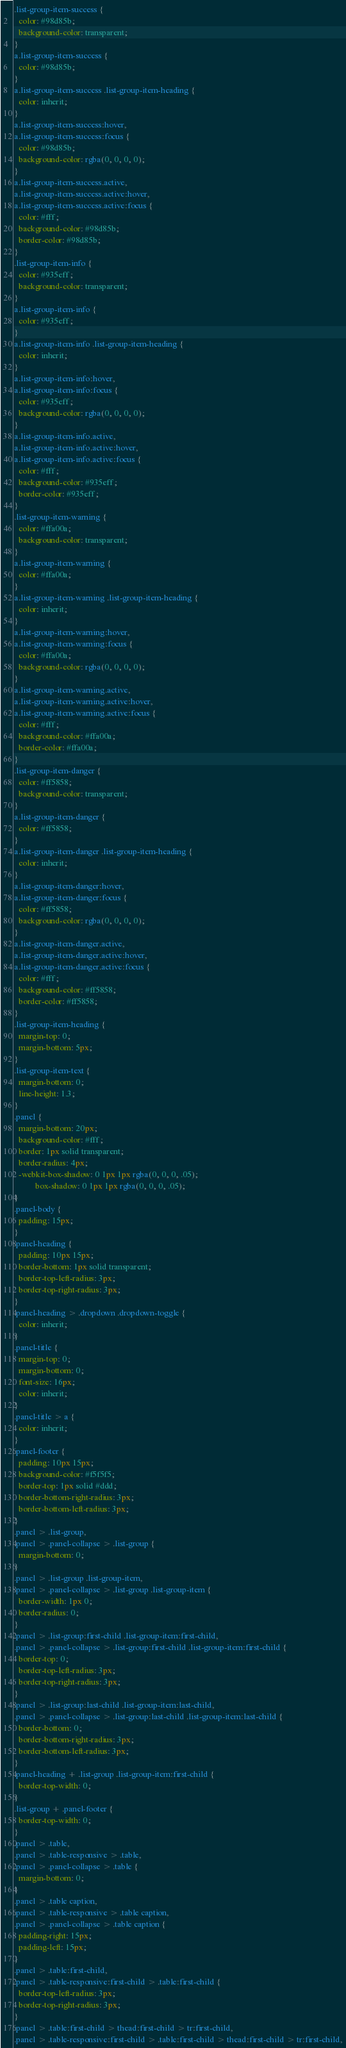Convert code to text. <code><loc_0><loc_0><loc_500><loc_500><_CSS_>.list-group-item-success {
  color: #98d85b;
  background-color: transparent;
}
a.list-group-item-success {
  color: #98d85b;
}
a.list-group-item-success .list-group-item-heading {
  color: inherit;
}
a.list-group-item-success:hover,
a.list-group-item-success:focus {
  color: #98d85b;
  background-color: rgba(0, 0, 0, 0);
}
a.list-group-item-success.active,
a.list-group-item-success.active:hover,
a.list-group-item-success.active:focus {
  color: #fff;
  background-color: #98d85b;
  border-color: #98d85b;
}
.list-group-item-info {
  color: #935eff;
  background-color: transparent;
}
a.list-group-item-info {
  color: #935eff;
}
a.list-group-item-info .list-group-item-heading {
  color: inherit;
}
a.list-group-item-info:hover,
a.list-group-item-info:focus {
  color: #935eff;
  background-color: rgba(0, 0, 0, 0);
}
a.list-group-item-info.active,
a.list-group-item-info.active:hover,
a.list-group-item-info.active:focus {
  color: #fff;
  background-color: #935eff;
  border-color: #935eff;
}
.list-group-item-warning {
  color: #ffa00a;
  background-color: transparent;
}
a.list-group-item-warning {
  color: #ffa00a;
}
a.list-group-item-warning .list-group-item-heading {
  color: inherit;
}
a.list-group-item-warning:hover,
a.list-group-item-warning:focus {
  color: #ffa00a;
  background-color: rgba(0, 0, 0, 0);
}
a.list-group-item-warning.active,
a.list-group-item-warning.active:hover,
a.list-group-item-warning.active:focus {
  color: #fff;
  background-color: #ffa00a;
  border-color: #ffa00a;
}
.list-group-item-danger {
  color: #ff5858;
  background-color: transparent;
}
a.list-group-item-danger {
  color: #ff5858;
}
a.list-group-item-danger .list-group-item-heading {
  color: inherit;
}
a.list-group-item-danger:hover,
a.list-group-item-danger:focus {
  color: #ff5858;
  background-color: rgba(0, 0, 0, 0);
}
a.list-group-item-danger.active,
a.list-group-item-danger.active:hover,
a.list-group-item-danger.active:focus {
  color: #fff;
  background-color: #ff5858;
  border-color: #ff5858;
}
.list-group-item-heading {
  margin-top: 0;
  margin-bottom: 5px;
}
.list-group-item-text {
  margin-bottom: 0;
  line-height: 1.3;
}
.panel {
  margin-bottom: 20px;
  background-color: #fff;
  border: 1px solid transparent;
  border-radius: 4px;
  -webkit-box-shadow: 0 1px 1px rgba(0, 0, 0, .05);
          box-shadow: 0 1px 1px rgba(0, 0, 0, .05);
}
.panel-body {
  padding: 15px;
}
.panel-heading {
  padding: 10px 15px;
  border-bottom: 1px solid transparent;
  border-top-left-radius: 3px;
  border-top-right-radius: 3px;
}
.panel-heading > .dropdown .dropdown-toggle {
  color: inherit;
}
.panel-title {
  margin-top: 0;
  margin-bottom: 0;
  font-size: 16px;
  color: inherit;
}
.panel-title > a {
  color: inherit;
}
.panel-footer {
  padding: 10px 15px;
  background-color: #f5f5f5;
  border-top: 1px solid #ddd;
  border-bottom-right-radius: 3px;
  border-bottom-left-radius: 3px;
}
.panel > .list-group,
.panel > .panel-collapse > .list-group {
  margin-bottom: 0;
}
.panel > .list-group .list-group-item,
.panel > .panel-collapse > .list-group .list-group-item {
  border-width: 1px 0;
  border-radius: 0;
}
.panel > .list-group:first-child .list-group-item:first-child,
.panel > .panel-collapse > .list-group:first-child .list-group-item:first-child {
  border-top: 0;
  border-top-left-radius: 3px;
  border-top-right-radius: 3px;
}
.panel > .list-group:last-child .list-group-item:last-child,
.panel > .panel-collapse > .list-group:last-child .list-group-item:last-child {
  border-bottom: 0;
  border-bottom-right-radius: 3px;
  border-bottom-left-radius: 3px;
}
.panel-heading + .list-group .list-group-item:first-child {
  border-top-width: 0;
}
.list-group + .panel-footer {
  border-top-width: 0;
}
.panel > .table,
.panel > .table-responsive > .table,
.panel > .panel-collapse > .table {
  margin-bottom: 0;
}
.panel > .table caption,
.panel > .table-responsive > .table caption,
.panel > .panel-collapse > .table caption {
  padding-right: 15px;
  padding-left: 15px;
}
.panel > .table:first-child,
.panel > .table-responsive:first-child > .table:first-child {
  border-top-left-radius: 3px;
  border-top-right-radius: 3px;
}
.panel > .table:first-child > thead:first-child > tr:first-child,
.panel > .table-responsive:first-child > .table:first-child > thead:first-child > tr:first-child,</code> 